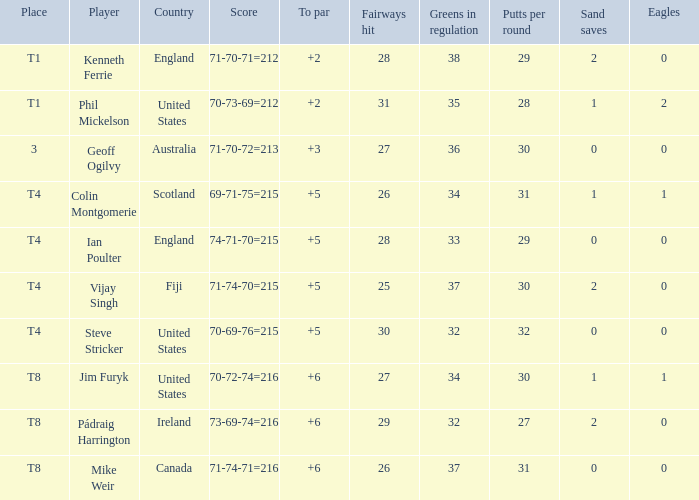Who had a score of 70-73-69=212? Phil Mickelson. Could you help me parse every detail presented in this table? {'header': ['Place', 'Player', 'Country', 'Score', 'To par', 'Fairways hit', 'Greens in regulation', 'Putts per round', 'Sand saves', 'Eagles'], 'rows': [['T1', 'Kenneth Ferrie', 'England', '71-70-71=212', '+2', '28', '38', '29', '2', '0'], ['T1', 'Phil Mickelson', 'United States', '70-73-69=212', '+2', '31', '35', '28', '1', '2'], ['3', 'Geoff Ogilvy', 'Australia', '71-70-72=213', '+3', '27', '36', '30', '0', '0'], ['T4', 'Colin Montgomerie', 'Scotland', '69-71-75=215', '+5', '26', '34', '31', '1', '1'], ['T4', 'Ian Poulter', 'England', '74-71-70=215', '+5', '28', '33', '29', '0', '0'], ['T4', 'Vijay Singh', 'Fiji', '71-74-70=215', '+5', '25', '37', '30', '2', '0'], ['T4', 'Steve Stricker', 'United States', '70-69-76=215', '+5', '30', '32', '32', '0', '0'], ['T8', 'Jim Furyk', 'United States', '70-72-74=216', '+6', '27', '34', '30', '1', '1'], ['T8', 'Pádraig Harrington', 'Ireland', '73-69-74=216', '+6', '29', '32', '27', '2', '0'], ['T8', 'Mike Weir', 'Canada', '71-74-71=216', '+6', '26', '37', '31', '0', '0']]} 